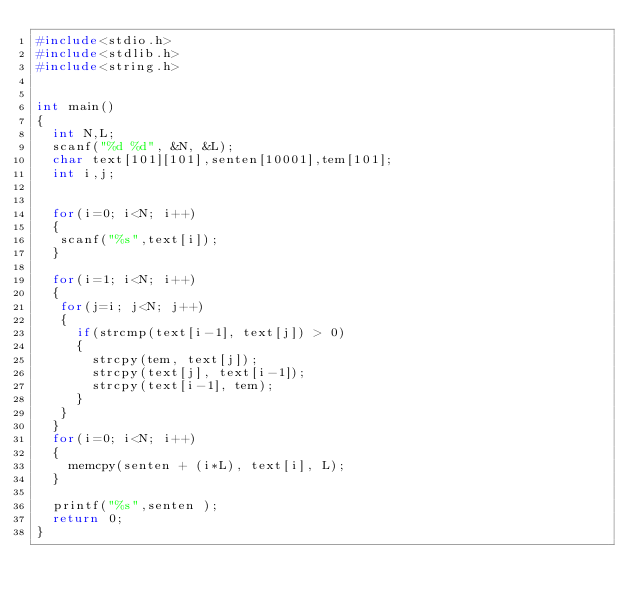Convert code to text. <code><loc_0><loc_0><loc_500><loc_500><_C_>#include<stdio.h>
#include<stdlib.h>
#include<string.h>


int main()
{
  int N,L;
  scanf("%d %d", &N, &L);
  char text[101][101],senten[10001],tem[101];
  int i,j;
  
  
  for(i=0; i<N; i++)
  {
   scanf("%s",text[i]); 
  }
  
  for(i=1; i<N; i++)
  {
   for(j=i; j<N; j++)
   {
     if(strcmp(text[i-1], text[j]) > 0)
     {
       strcpy(tem, text[j]);
       strcpy(text[j], text[i-1]);
       strcpy(text[i-1], tem);
     }
   }
  }
  for(i=0; i<N; i++)
  {
  	memcpy(senten + (i*L), text[i], L);
  }
  
  printf("%s",senten );
  return 0;
}
</code> 